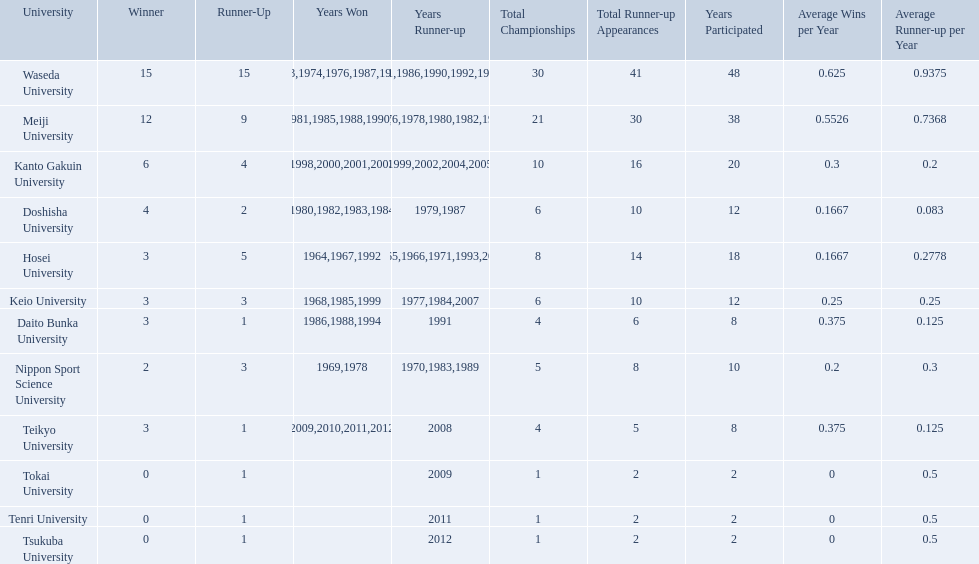What are all of the universities? Waseda University, Meiji University, Kanto Gakuin University, Doshisha University, Hosei University, Keio University, Daito Bunka University, Nippon Sport Science University, Teikyo University, Tokai University, Tenri University, Tsukuba University. And their scores? 15, 12, 6, 4, 3, 3, 3, 2, 3, 0, 0, 0. Which university scored won the most? Waseda University. Which university had 6 wins? Kanto Gakuin University. Which university had 12 wins? Meiji University. Which university had more than 12 wins? Waseda University. 